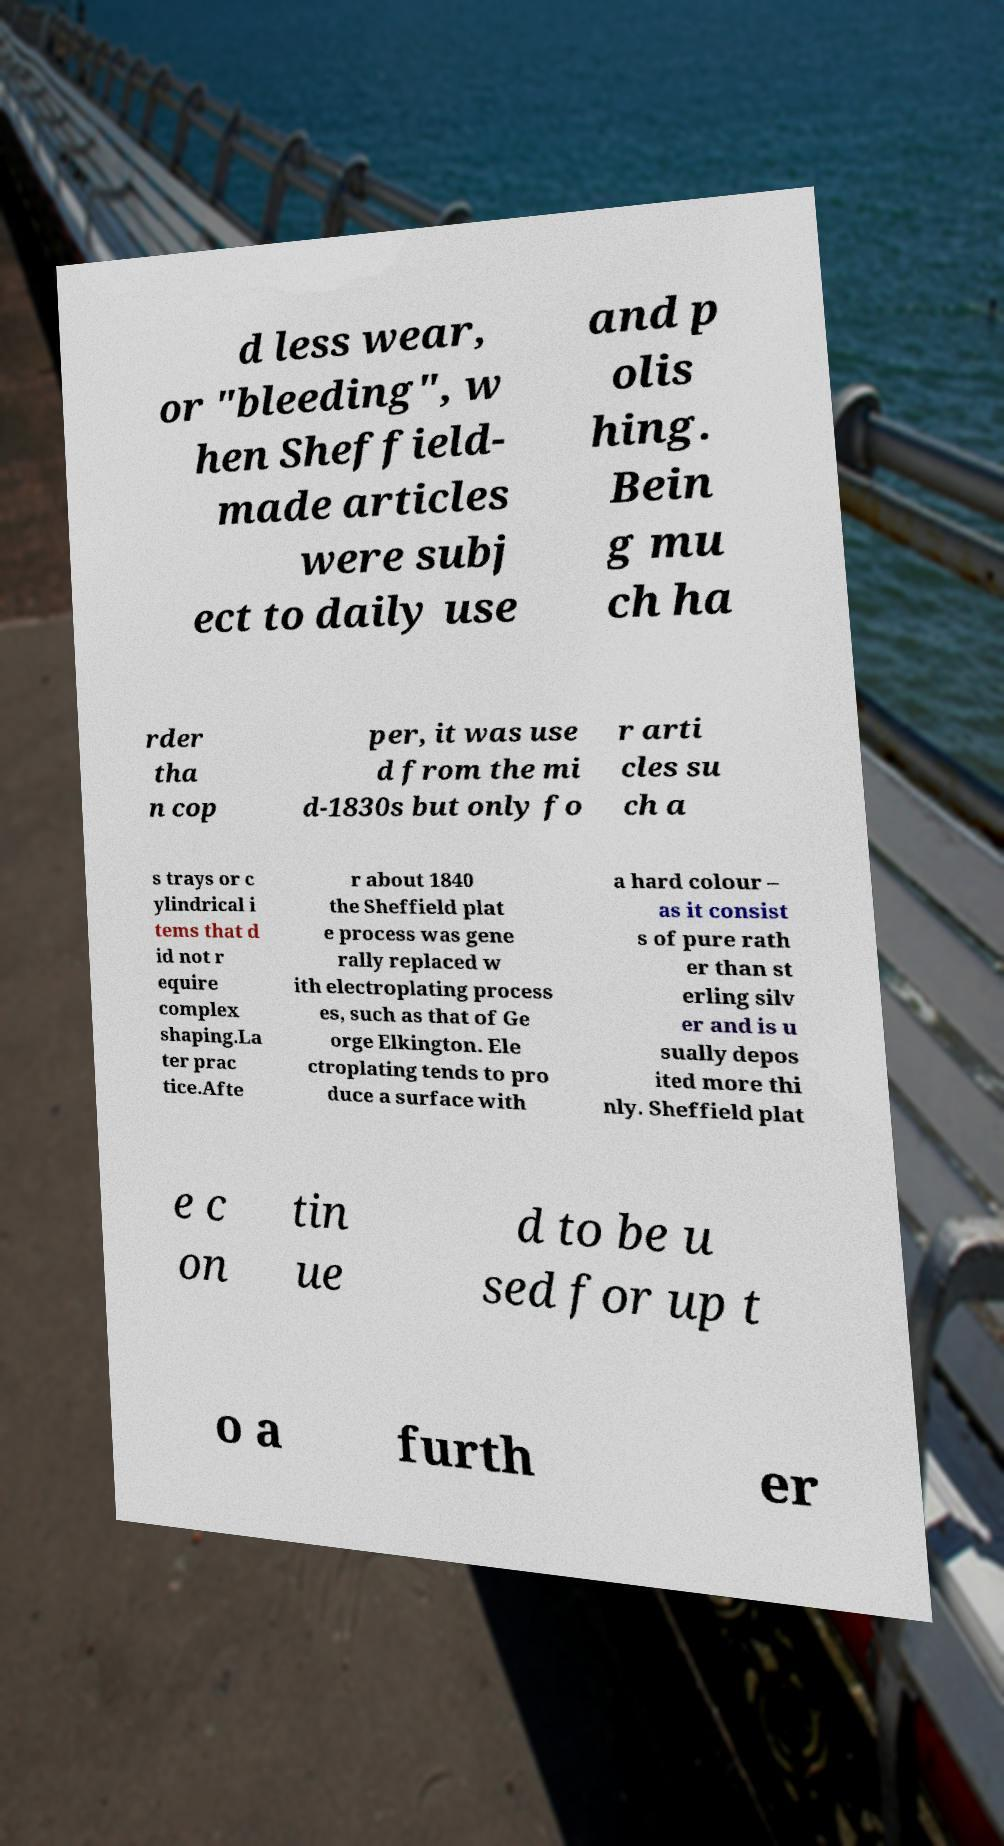For documentation purposes, I need the text within this image transcribed. Could you provide that? d less wear, or "bleeding", w hen Sheffield- made articles were subj ect to daily use and p olis hing. Bein g mu ch ha rder tha n cop per, it was use d from the mi d-1830s but only fo r arti cles su ch a s trays or c ylindrical i tems that d id not r equire complex shaping.La ter prac tice.Afte r about 1840 the Sheffield plat e process was gene rally replaced w ith electroplating process es, such as that of Ge orge Elkington. Ele ctroplating tends to pro duce a surface with a hard colour – as it consist s of pure rath er than st erling silv er and is u sually depos ited more thi nly. Sheffield plat e c on tin ue d to be u sed for up t o a furth er 